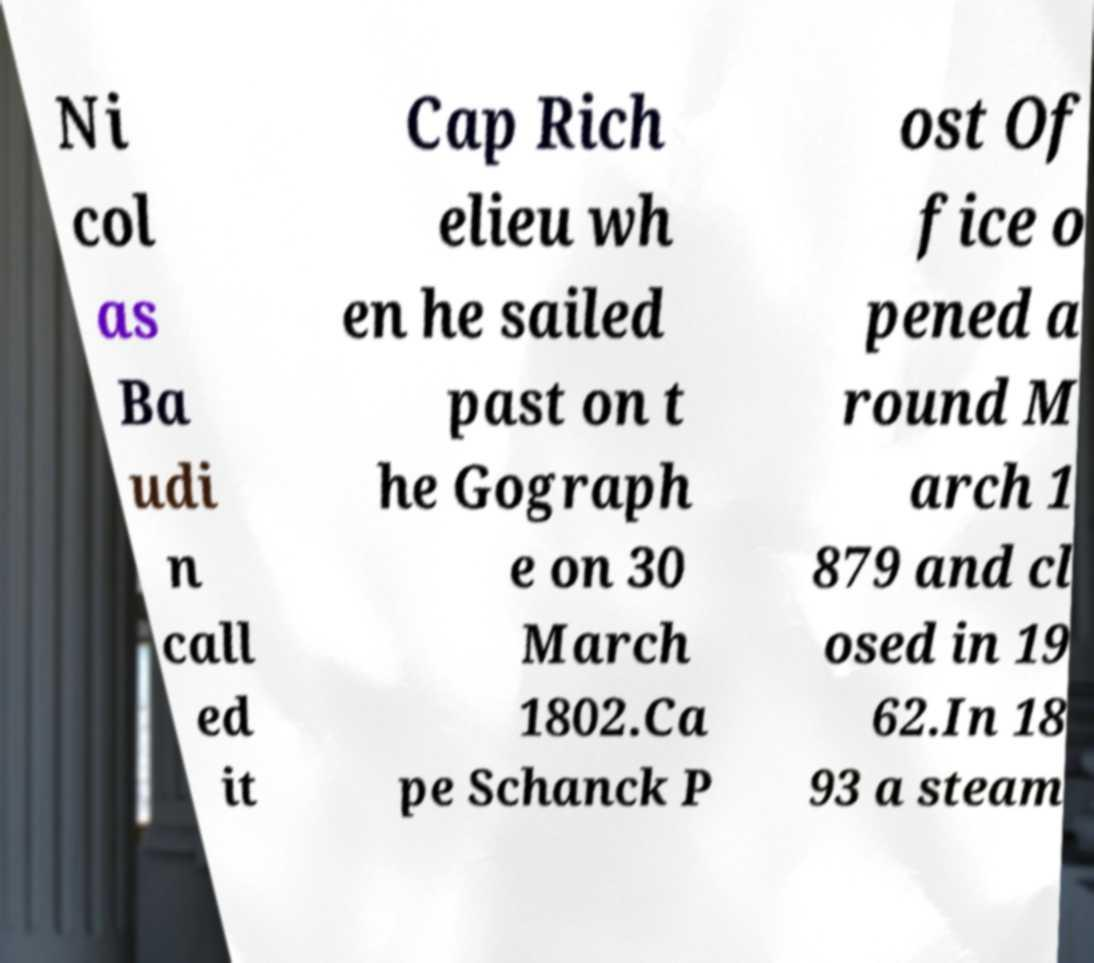For documentation purposes, I need the text within this image transcribed. Could you provide that? Ni col as Ba udi n call ed it Cap Rich elieu wh en he sailed past on t he Gograph e on 30 March 1802.Ca pe Schanck P ost Of fice o pened a round M arch 1 879 and cl osed in 19 62.In 18 93 a steam 